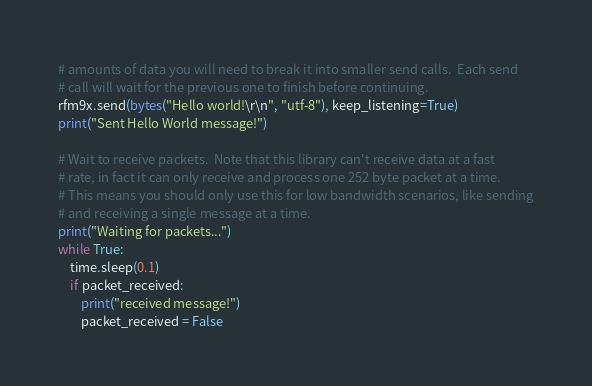Convert code to text. <code><loc_0><loc_0><loc_500><loc_500><_Python_># amounts of data you will need to break it into smaller send calls.  Each send
# call will wait for the previous one to finish before continuing.
rfm9x.send(bytes("Hello world!\r\n", "utf-8"), keep_listening=True)
print("Sent Hello World message!")

# Wait to receive packets.  Note that this library can't receive data at a fast
# rate, in fact it can only receive and process one 252 byte packet at a time.
# This means you should only use this for low bandwidth scenarios, like sending
# and receiving a single message at a time.
print("Waiting for packets...")
while True:
    time.sleep(0.1)
    if packet_received:
        print("received message!")
        packet_received = False
</code> 